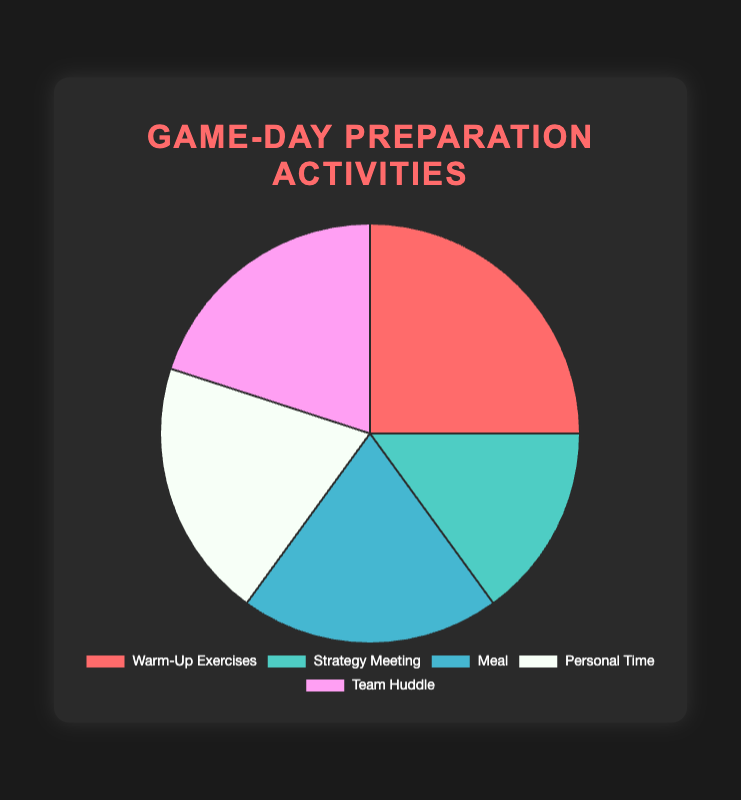What activity takes up the largest portion of game-day preparation? By visually examining the figure, the segment labeled "Warm-Up Exercises" appears largest and has the label 25%. This is greater than the other segments.
Answer: Warm-Up Exercises Which activities have equal portions of game-day preparation? Checking the figure, "Meal," "Personal Time," and "Team Huddle" each have equal portions indicating 20%.
Answer: Meal, Personal Time, Team Huddle What is the combined percentage for Strategy Meeting and Personal Time? Adding the percentages for Strategy Meeting and Personal Time, we get 15% + 20% = 35%.
Answer: 35% How does the time spent on Strategy Meeting compare to time spent on Meal? Visually, the percentage for Strategy Meeting is 15%, whereas Meal is at 20%. Since 15% is less than 20%, Strategy Meeting takes up less time.
Answer: Less Which segments have different colors and what are they? The visualization shows different colors for each segment: Warm-Up Exercises (Red), Strategy Meeting (Teal), Meal (Blue), Personal Time (White), and Team Huddle (Pink).
Answer: Warm-Up Exercises (Red), Strategy Meeting (Teal), Meal (Blue), Personal Time (White), Team Huddle (Pink) If you combined the time for Warm-Up Exercises and Strategy Meeting, what percentage of game-day preparation would that be? Adding the percentages, Warm-Up Exercises (25%) and Strategy Meeting (15%) sum to 25% + 15% = 40%.
Answer: 40% Which activity takes up exactly one-fifth of the game-day preparation time? One-fifth corresponds to 20%. Checking the figure, Meal, Personal Time, and Team Huddle each occupy 20%. Hence, all these activities take up one-fifth of the time.
Answer: Meal, Personal Time, Team Huddle Between Warm-Up Exercises and Team Huddle, which has a greater portion and by how much? Warm-Up Exercises has 25% and Team Huddle has 20%. The difference is 25% - 20% = 5%. Warm-Up Exercises has a greater portion by 5%.
Answer: Warm-Up Exercises, 5% What's the average percentage for the activities except Warm-Up Exercises? Summing the percentages of the other four activities (15% + 20% + 20% + 20% = 75%) and then dividing by 4, the average is 75%/4 = 18.75%.
Answer: 18.75% 